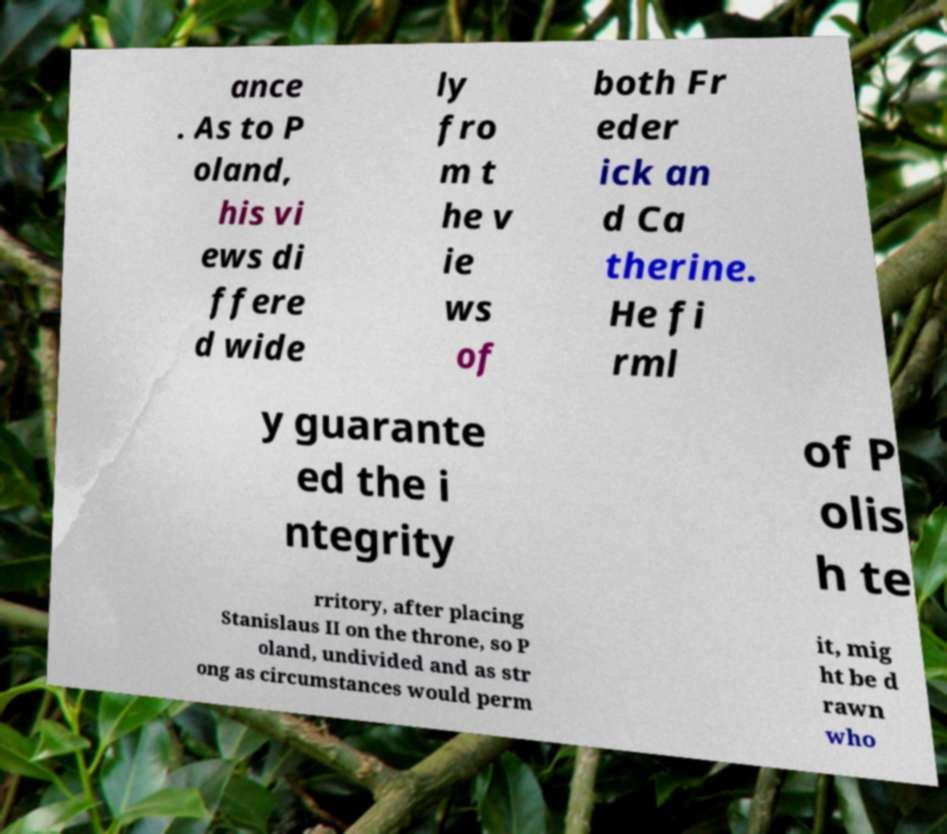Please identify and transcribe the text found in this image. ance . As to P oland, his vi ews di ffere d wide ly fro m t he v ie ws of both Fr eder ick an d Ca therine. He fi rml y guarante ed the i ntegrity of P olis h te rritory, after placing Stanislaus II on the throne, so P oland, undivided and as str ong as circumstances would perm it, mig ht be d rawn who 